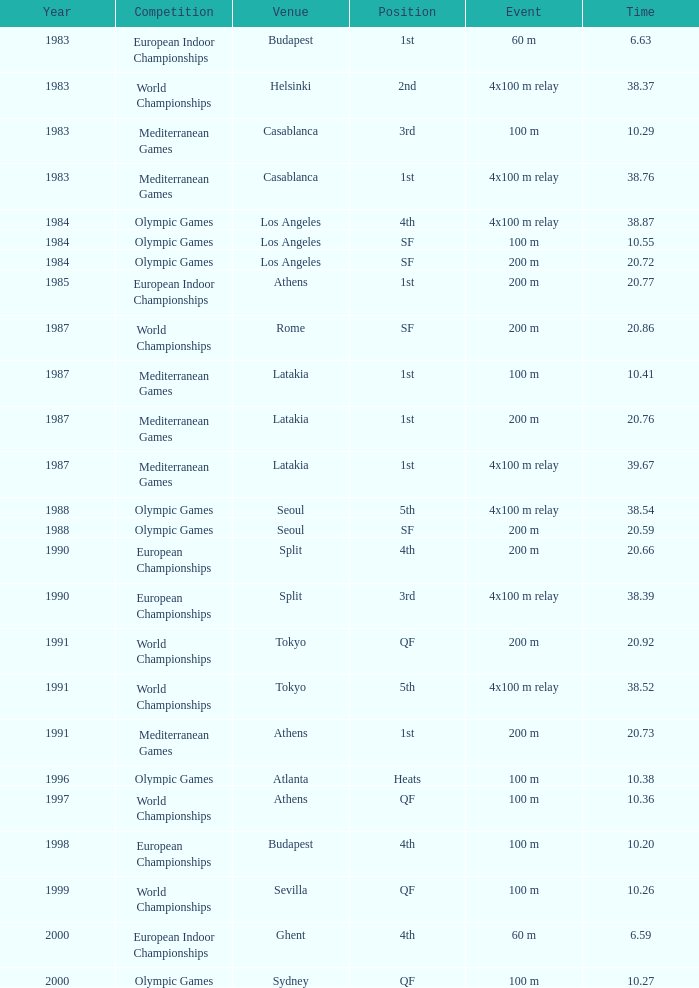What Venue has a Year smaller than 1991, Time larger than 10.29, Competition of mediterranean games, and Event of 4x100 m relay? Casablanca, Latakia. 